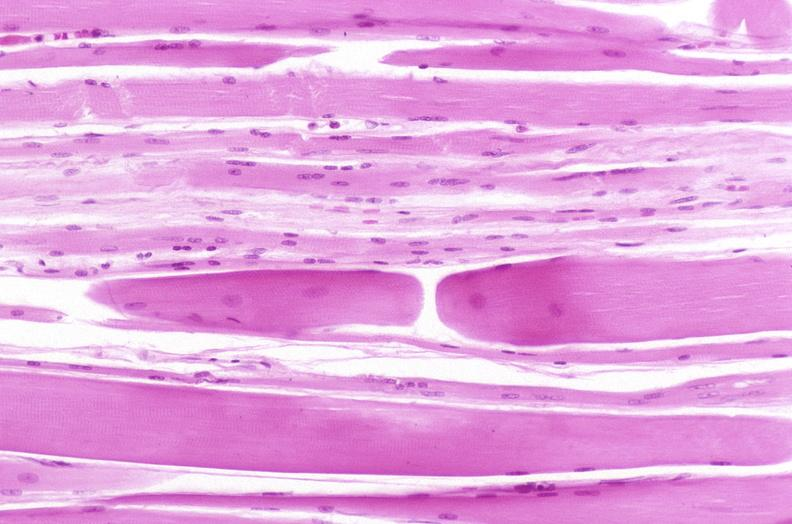does this image show skeletal muscle, atrophy due to immobilization cast?
Answer the question using a single word or phrase. Yes 